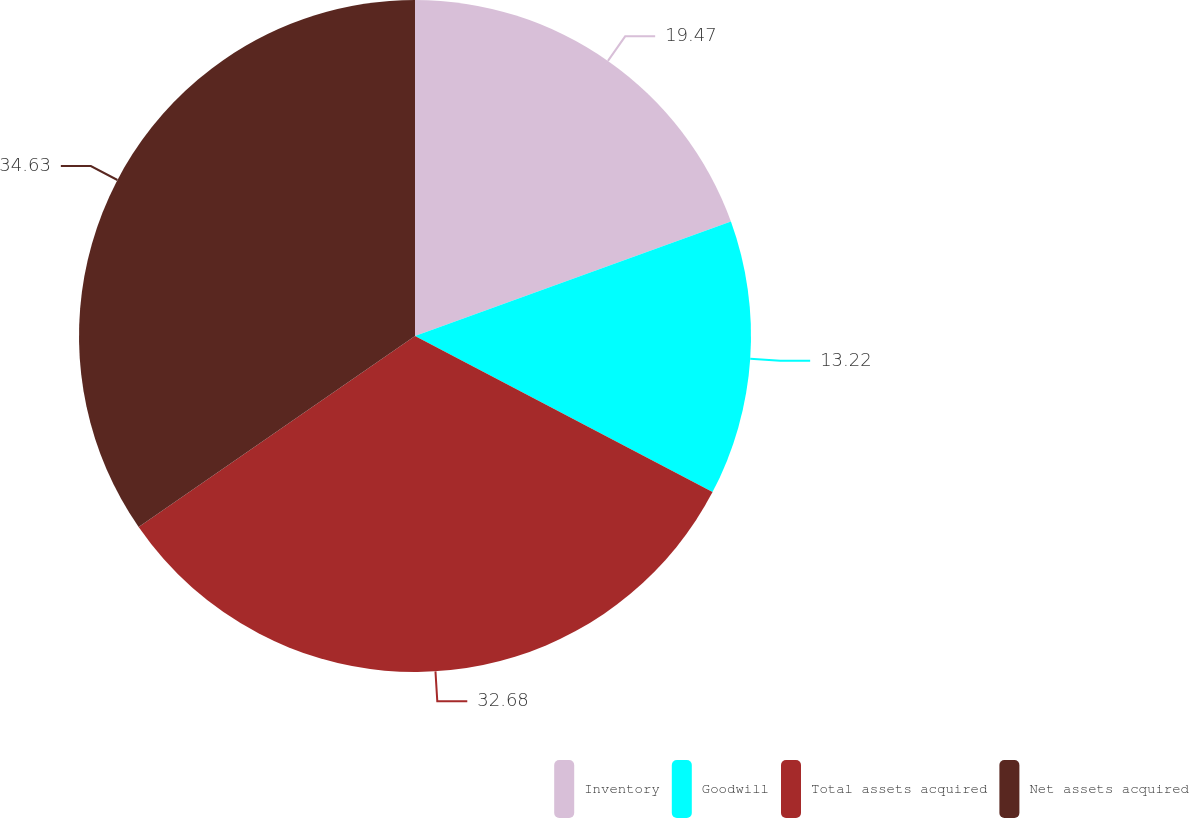<chart> <loc_0><loc_0><loc_500><loc_500><pie_chart><fcel>Inventory<fcel>Goodwill<fcel>Total assets acquired<fcel>Net assets acquired<nl><fcel>19.47%<fcel>13.22%<fcel>32.68%<fcel>34.63%<nl></chart> 